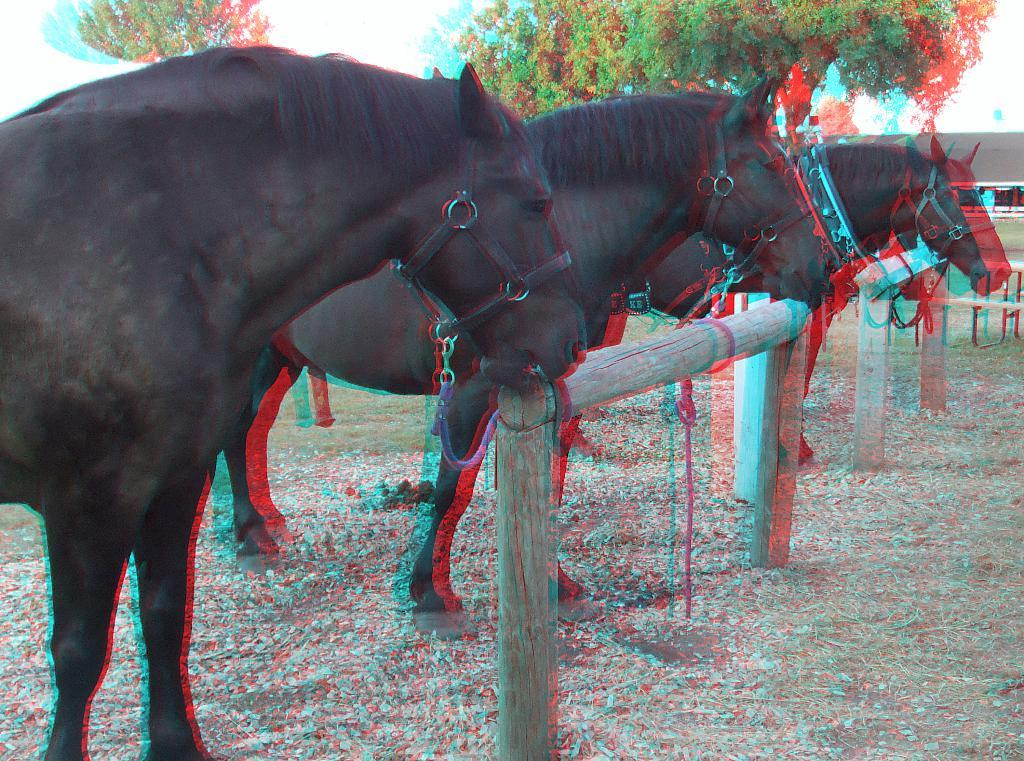How many horses are in the image? There are three horses in the image. What is the condition of the horses in the image? The horses are tied to a wooden pole. What type of vegetation is present in the image? There are trees in the image. What structures can be seen in the image? There are poles and a house in the image. What is visible in the background of the image? The sky is visible in the image. What type of basketball court can be seen in the image? There is no basketball court present in the image. What are the horses learning in the image? The horses are not shown learning anything in the image. 